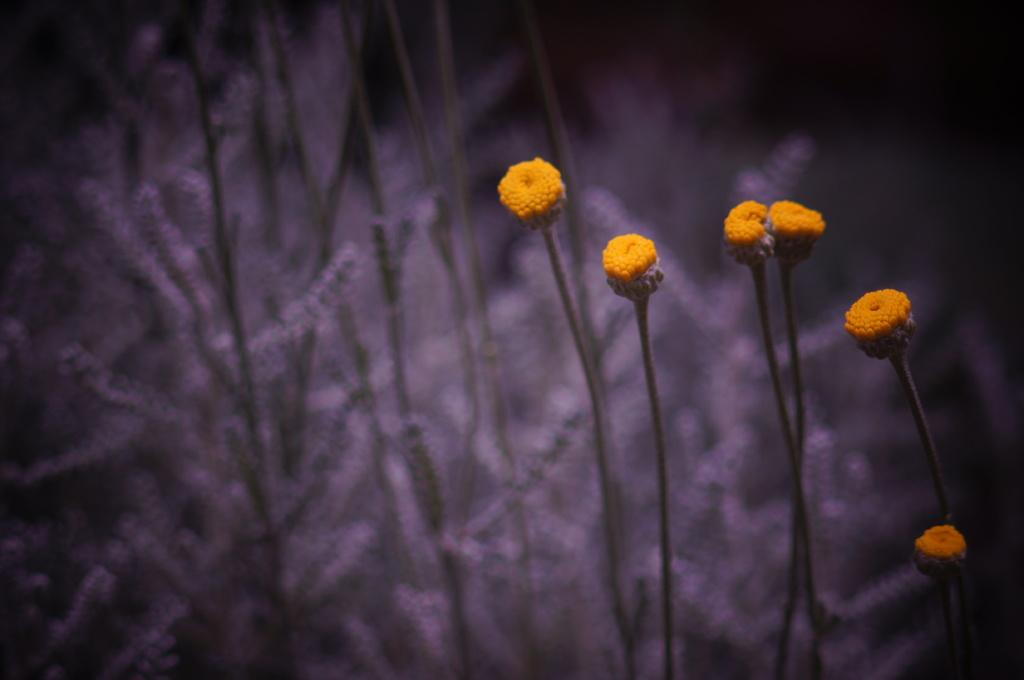What color are the flowers in the image? The flowers in the image are orange. How are the flowers attached to the stems? The flowers are on stems in the image. What can be seen in the background of the image? There are plants in the background of the image. Can you tell me how many cherries are hanging from the flowers in the image? There are no cherries present in the image; it features orange flowers on stems. 